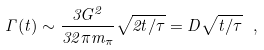<formula> <loc_0><loc_0><loc_500><loc_500>\Gamma ( t ) \sim \frac { 3 G ^ { 2 } } { 3 2 \pi m _ { \pi } } \sqrt { 2 t / \tau } = D \sqrt { t / \tau } \ ,</formula> 